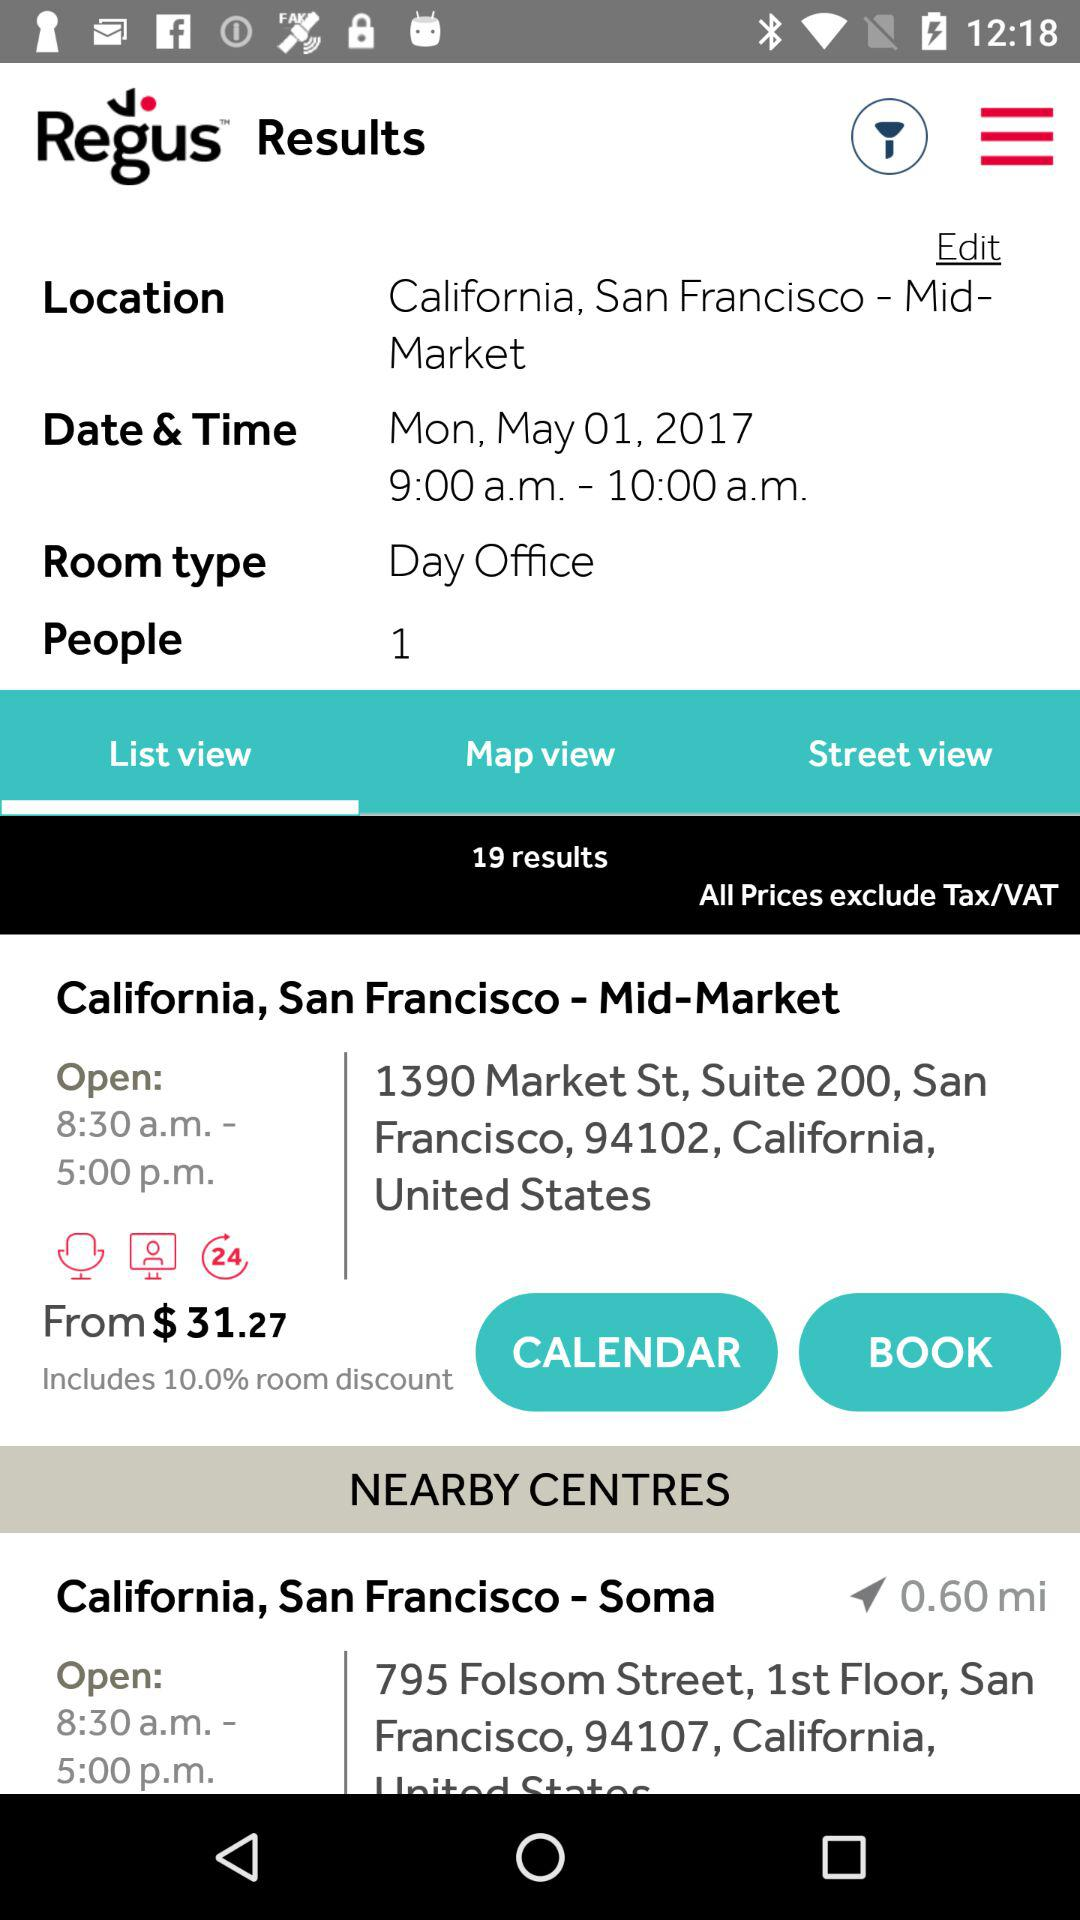How many people can the day office fit?
Answer the question using a single word or phrase. 1 